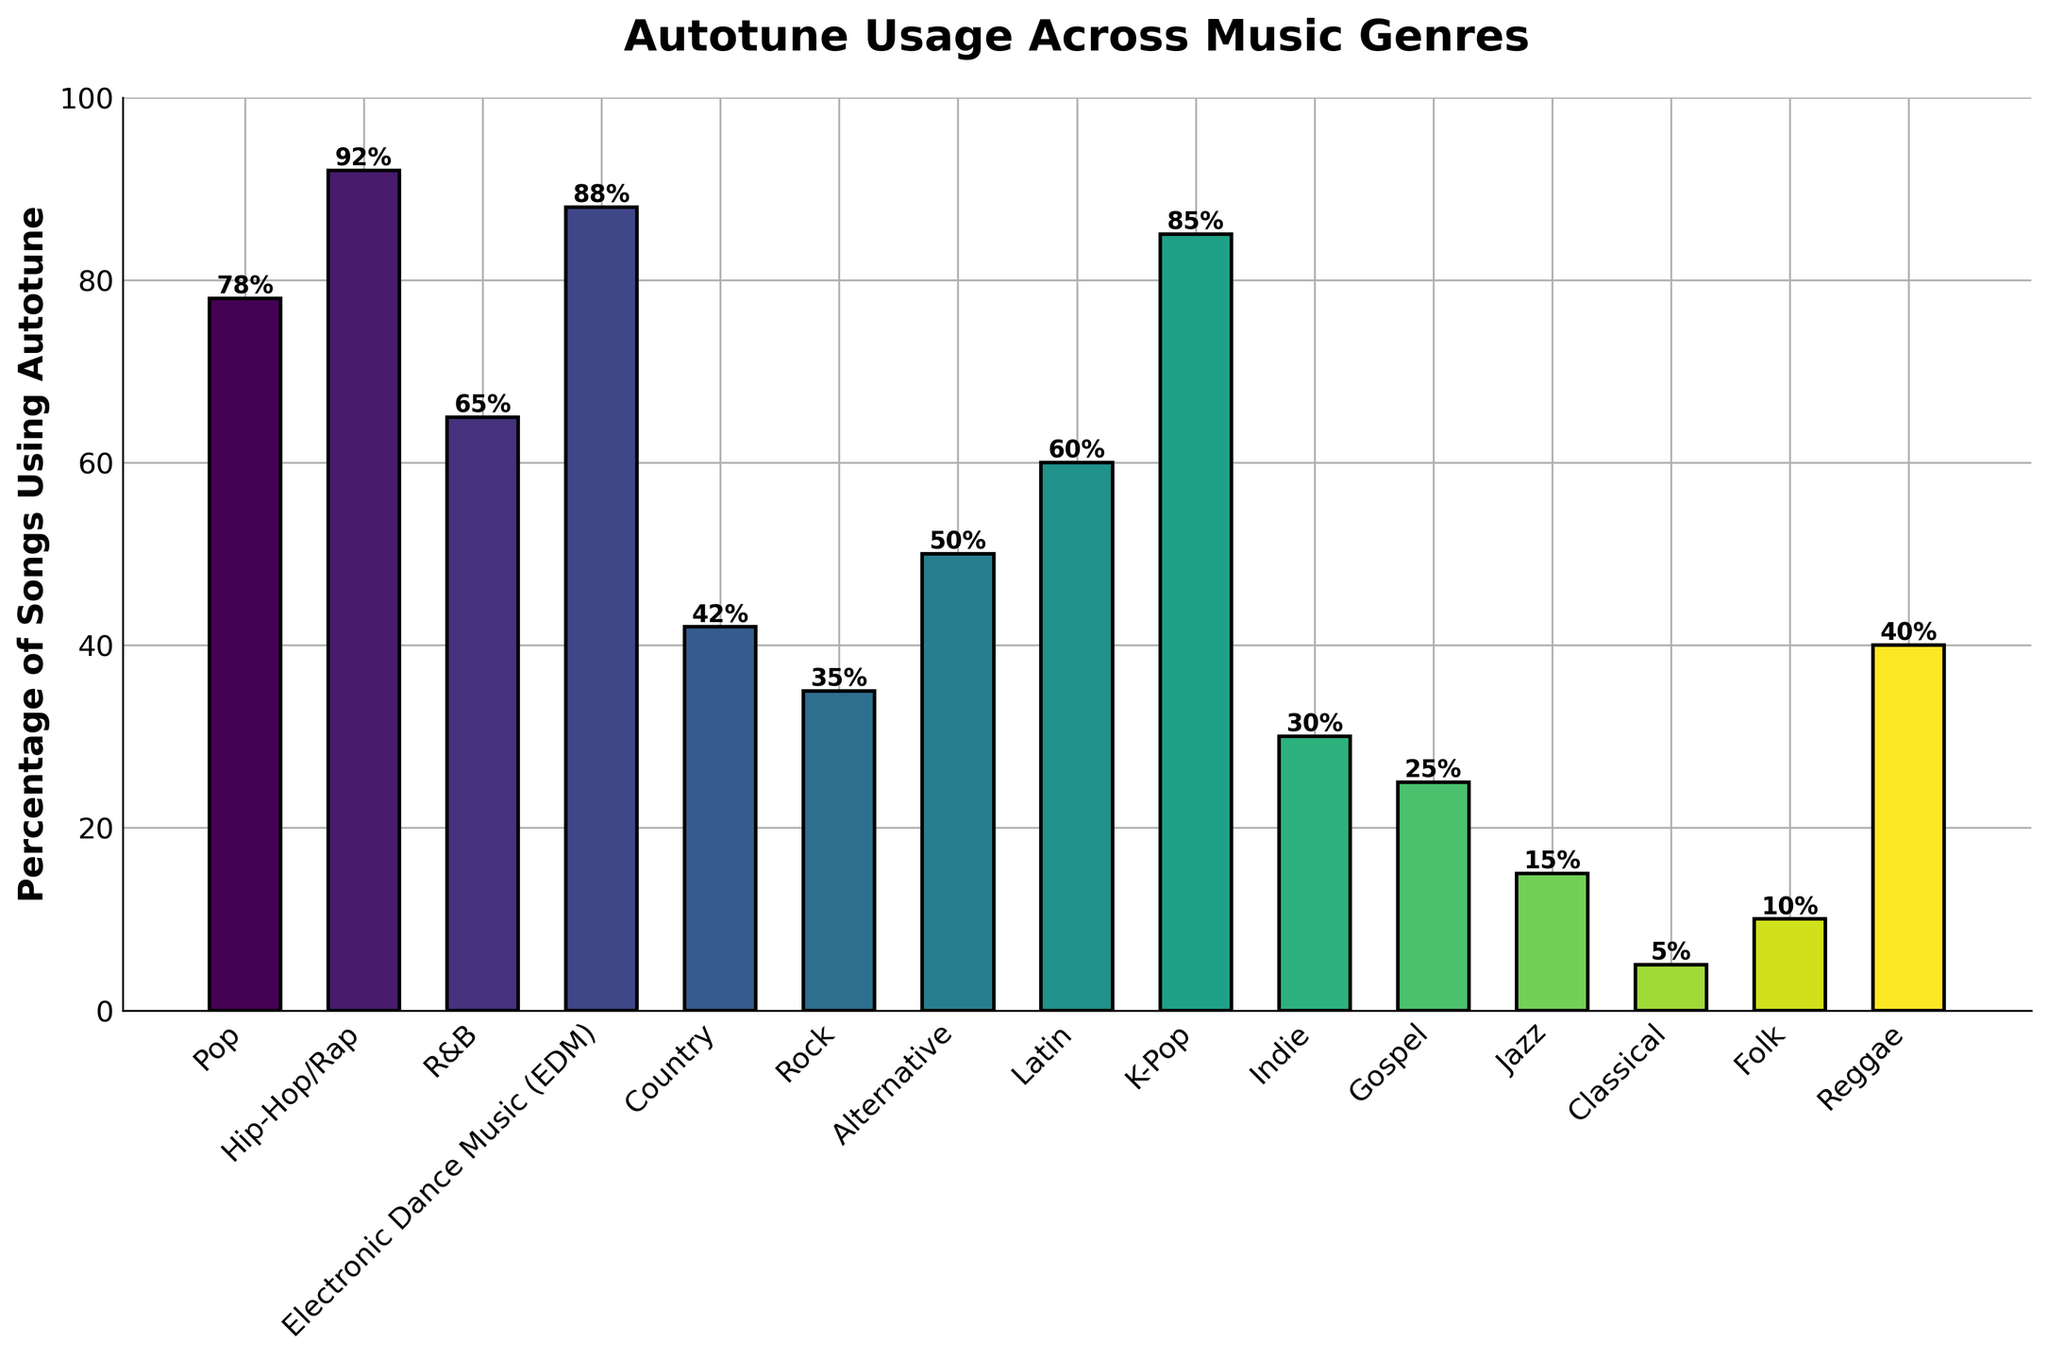Which genre has the highest percentage of songs using autotune? By looking at the height of the bars, we can see that Hip-Hop/Rap has the tallest bar, which means it has the highest percentage of songs using autotune.
Answer: Hip-Hop/Rap Which three genres have the lowest percentage of songs using autotune? By examining and comparing the heights of the bars, we can see that Classical, Jazz, and Folk have the shortest bars, indicating the lowest percentages of songs using autotune.
Answer: Classical, Jazz, Folk What is the difference in autotune usage between Pop and Rock genres? From the bar chart, the percentage of songs using autotune in Pop is 78% and in Rock is 35%. The difference is calculated by subtracting these two values.
Answer: 43% Is the percentage of songs using autotune higher in Latin or Alternative genre? By comparing the heights of the bars for Latin (60%) and Alternative (50%), it’s clear that the Latin bar is taller.
Answer: Latin What is the average percentage of songs using autotune in Pop, Hip-Hop/Rap, and EDM genres? To calculate the average, sum up the percentages for Pop (78%), Hip-Hop/Rap (92%), and EDM (88%), then divide by the number of genres (3). (78 + 92 + 88) / 3 = 86
Answer: 86% Which genre has a higher percentage of autotune usage, Country or Reggae? By comparing the height of the bars for Country (42%) and Reggae (40%), Country has a slightly higher percentage.
Answer: Country What's the sum of the percentages of songs using autotune for Indie, Gospel, and Jazz genres? First, find the percentages for Indie (30%), Gospel (25%), and Jazz (15%). Then, add these values together: 30 + 25 + 15 = 70.
Answer: 70% Are there more genres with over 50% or under 50% autotune usage? Count the bars with percentages over 50% (5 genres: Pop, Hip-Hop/Rap, EDM, K-Pop, Latin) and those with under 50% (10 genres: R&B, Country, Rock, Alternative, Indie, Gospel, Jazz, Classical, Folk, Reggae). There are more genres with under 50%.
Answer: Under 50% Which genre's bar color is closest to green? The bar closest to green is visually identified within the colormap used; K-Pop has a greenish hue.
Answer: K-Pop How many genres have more than twice the percentage of autotune usage than Folk? Folk has 10%. The genres with over 20% usage are Pop (78%), Hip-Hop/Rap (92%), R&B (65%), EDM (88%), Country (42%), Rock (35%), Alternative (50%), Latin (60%), K-Pop (85%), Indie (30%), and Reggae (40%). Counting these totals to 11 genres.
Answer: 11 